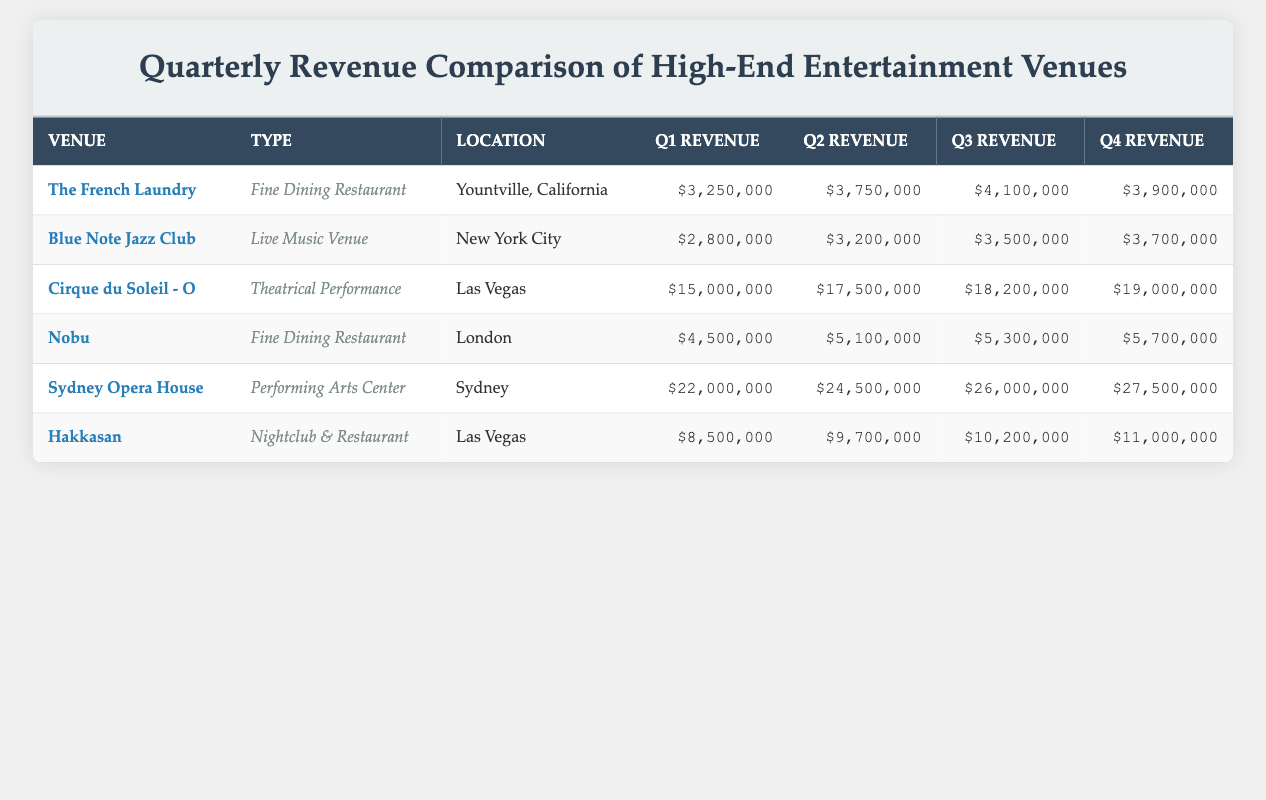What is the total revenue generated by the Sydney Opera House in Q4? The revenue for the Sydney Opera House in Q4 is listed as $27,500,000.
Answer: $27,500,000 Which venue had the highest Q2 revenue? The venue with the highest Q2 revenue is Sydney Opera House, generating $24,500,000.
Answer: Sydney Opera House What was the average revenue for Nobu across all four quarters? The total revenue for Nobu is calculated by adding all quarters: (4,500,000 + 5,100,000 + 5,300,000 + 5,700,000) = 20,600,000. There are four quarters, so the average is 20,600,000 / 4 = 5,150,000.
Answer: $5,150,000 Did Blue Note Jazz Club generate more revenue in Q4 than in Q3? Blue Note Jazz Club had revenue of $3,700,000 in Q4 and $3,500,000 in Q3, so yes, it generated more revenue in Q4.
Answer: Yes What is the difference in revenue between Hakkasan Q4 and The French Laundry Q4? The revenue for Hakkasan in Q4 is $11,000,000 and for The French Laundry is $3,900,000. The difference is calculated as 11,000,000 - 3,900,000 = 7,100,000.
Answer: $7,100,000 Which venue had the largest revenue growth from Q1 to Q4? To find the largest revenue growth, we calculate the differences for each venue: The French Laundry (3,900,000 - 3,250,000 = 650,000), Blue Note Jazz Club (3,700,000 - 2,800,000 = 900,000), Cirque du Soleil - O (19,000,000 - 15,000,000 = 4,000,000), Nobu (5,700,000 - 4,500,000 = 1,200,000), Sydney Opera House (27,500,000 - 22,000,000 = 5,500,000), Hakkasan (11,000,000 - 8,500,000 = 2,500,000). The largest growth is from Cirque du Soleil - O with $4,000,000.
Answer: Cirque du Soleil - O What is the total revenue for all venues in Q3? To find the total revenue for Q3, we sum the revenue: 4,100,000 (French Laundry) + 3,500,000 (Blue Note) + 18,200,000 (Cirque du Soleil) + 5,300,000 (Nobu) + 26,000,000 (Sydney Opera House) + 10,200,000 (Hakkasan) = 67,300,000.
Answer: $67,300,000 Is Hakkasan's Q2 revenue greater than Cirque du Soleil's Q1 revenue? Hakkasan's Q2 revenue is $9,700,000 and Cirque du Soleil's Q1 revenue is $15,000,000. Since 9,700,000 is less than 15,000,000, the answer is no.
Answer: No 